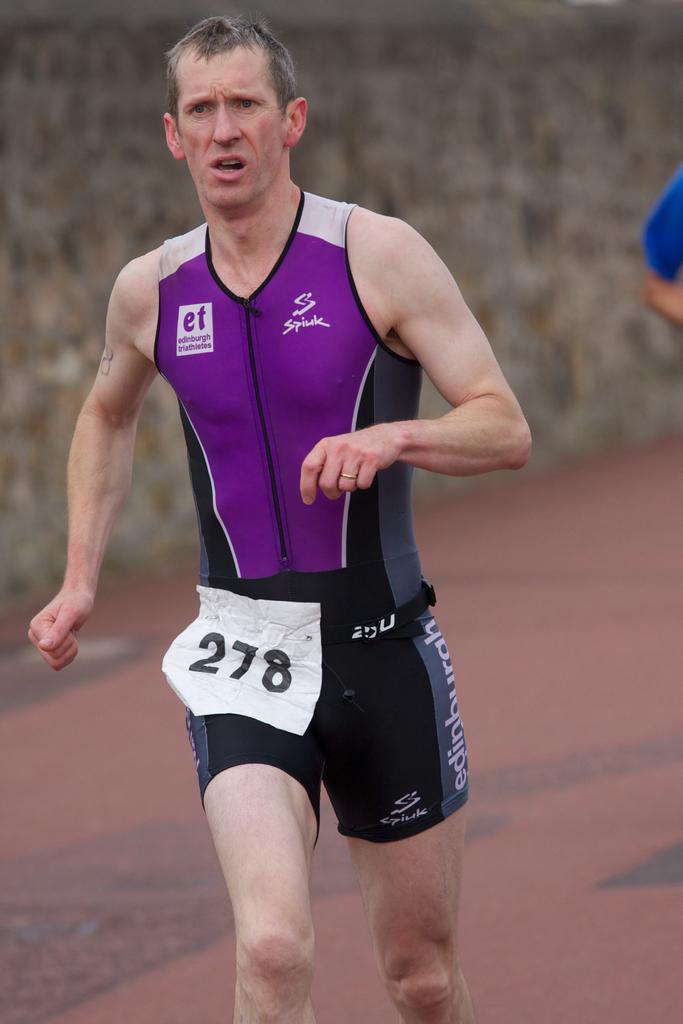What is the brand of the runners top?
Provide a short and direct response. Spiuk. 